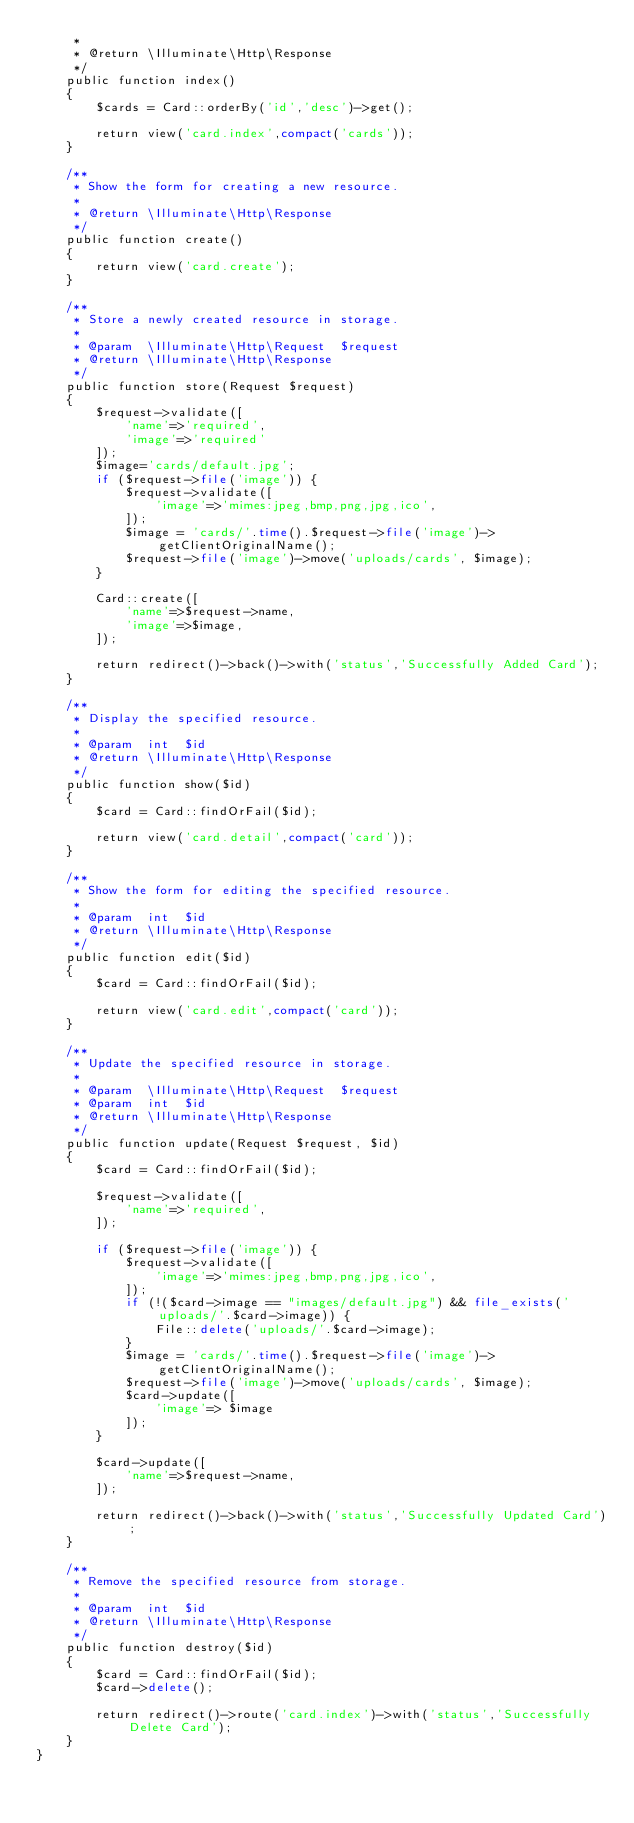<code> <loc_0><loc_0><loc_500><loc_500><_PHP_>     *
     * @return \Illuminate\Http\Response
     */
    public function index()
    {
        $cards = Card::orderBy('id','desc')->get();

        return view('card.index',compact('cards'));
    }

    /**
     * Show the form for creating a new resource.
     *
     * @return \Illuminate\Http\Response
     */
    public function create()
    {
        return view('card.create');
    }

    /**
     * Store a newly created resource in storage.
     *
     * @param  \Illuminate\Http\Request  $request
     * @return \Illuminate\Http\Response
     */
    public function store(Request $request)
    {
        $request->validate([
            'name'=>'required',
            'image'=>'required'
        ]);
        $image='cards/default.jpg';
        if ($request->file('image')) {
            $request->validate([
                'image'=>'mimes:jpeg,bmp,png,jpg,ico',
            ]);
            $image = 'cards/'.time().$request->file('image')->getClientOriginalName();
            $request->file('image')->move('uploads/cards', $image);
        }

        Card::create([
            'name'=>$request->name,
            'image'=>$image,
        ]);

        return redirect()->back()->with('status','Successfully Added Card');
    }

    /**
     * Display the specified resource.
     *
     * @param  int  $id
     * @return \Illuminate\Http\Response
     */
    public function show($id)
    {
        $card = Card::findOrFail($id);

        return view('card.detail',compact('card'));
    }

    /**
     * Show the form for editing the specified resource.
     *
     * @param  int  $id
     * @return \Illuminate\Http\Response
     */
    public function edit($id)
    {
        $card = Card::findOrFail($id);

        return view('card.edit',compact('card'));
    }

    /**
     * Update the specified resource in storage.
     *
     * @param  \Illuminate\Http\Request  $request
     * @param  int  $id
     * @return \Illuminate\Http\Response
     */
    public function update(Request $request, $id)
    {
        $card = Card::findOrFail($id);

        $request->validate([
            'name'=>'required',
        ]);

        if ($request->file('image')) {
            $request->validate([
                'image'=>'mimes:jpeg,bmp,png,jpg,ico',
            ]);
            if (!($card->image == "images/default.jpg") && file_exists('uploads/'.$card->image)) {
                File::delete('uploads/'.$card->image);
            }
            $image = 'cards/'.time().$request->file('image')->getClientOriginalName();
            $request->file('image')->move('uploads/cards', $image);
            $card->update([
                'image'=> $image
            ]);
        }

        $card->update([
            'name'=>$request->name,
        ]);

        return redirect()->back()->with('status','Successfully Updated Card');
    }

    /**
     * Remove the specified resource from storage.
     *
     * @param  int  $id
     * @return \Illuminate\Http\Response
     */
    public function destroy($id)
    {
        $card = Card::findOrFail($id);
        $card->delete();

        return redirect()->route('card.index')->with('status','Successfully Delete Card');
    }
}
</code> 